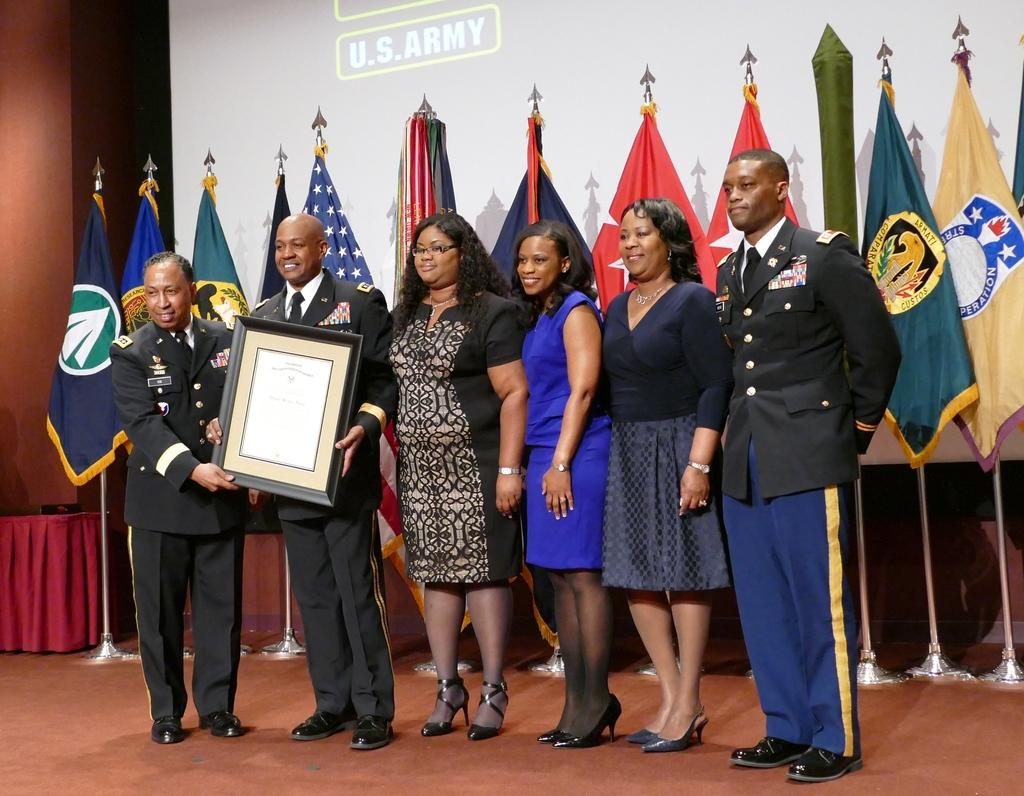How many people are in the image? There is a group of people in the image. What are the people doing in the image? The people are standing on the floor and smiling. What can be seen in the background of the image? There is a screen, flags with poles, a cloth, and a wall in the background of the image. What direction is the current flowing in the image? There is no reference to a current or water in the image, so it's not possible to determine the direction of any current. What is the health status of the people in the image? There is no information about the health status of the people in the image, as the focus is on their actions and expressions. 